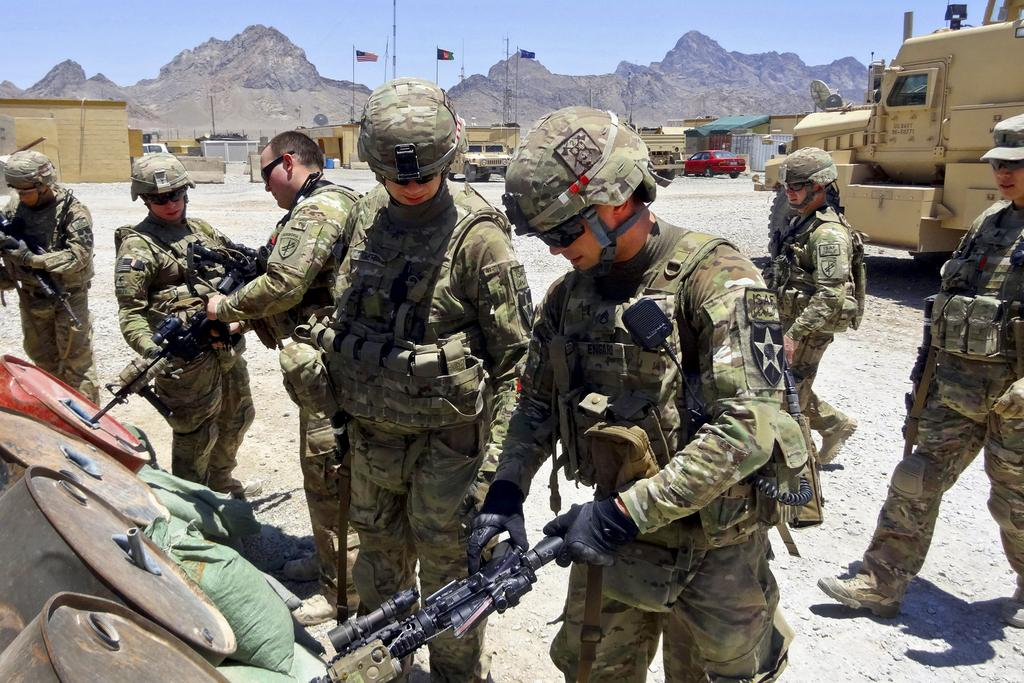What are the main subjects in the center of the image? There are soldiers standing in the center of the image. What can be seen in the distance behind the soldiers? There are mountains in the background of the image. Are there any symbols or emblems present in the image? Yes, there are flags present in the image. What type of vehicles can be seen in the image? There are cars visible in the image. How many chickens are running around the soldiers in the image? There are no chickens present in the image. What is the temperature of the environment in the image? The provided facts do not give any information about the temperature, so it cannot be determined from the image. 